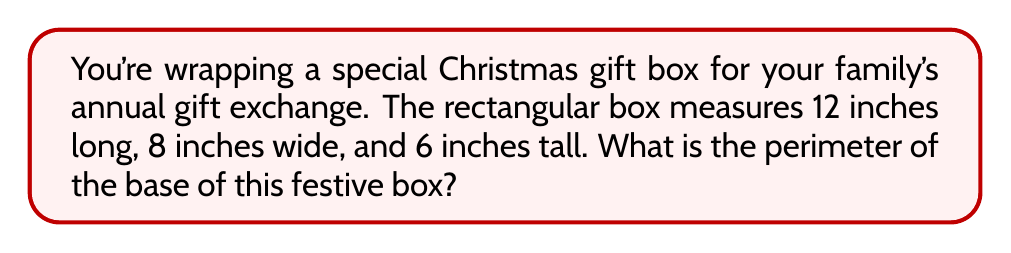Can you solve this math problem? Let's approach this step-by-step:

1) The base of a rectangular box is a rectangle.

2) The perimeter of a rectangle is the sum of all its sides.

3) For a rectangle, the perimeter formula is:
   $$P = 2l + 2w$$
   where $P$ is the perimeter, $l$ is the length, and $w$ is the width.

4) We're given:
   - Length ($l$) = 12 inches
   - Width ($w$) = 8 inches

5) Let's substitute these values into our formula:
   $$P = 2(12) + 2(8)$$

6) Simplify:
   $$P = 24 + 16 = 40$$

Therefore, the perimeter of the base of the Christmas gift box is 40 inches.

[asy]
unitsize(0.3cm);
draw((0,0)--(12,0)--(12,8)--(0,8)--cycle);
label("12\"", (6,-1));
label("8\"", (-1,4));
[/asy]
Answer: 40 inches 